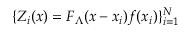<formula> <loc_0><loc_0><loc_500><loc_500>\{ Z _ { i } ( x ) = F _ { \Lambda } ( x - x _ { i } ) f ( x _ { i } ) \} _ { i = 1 } ^ { N }</formula> 